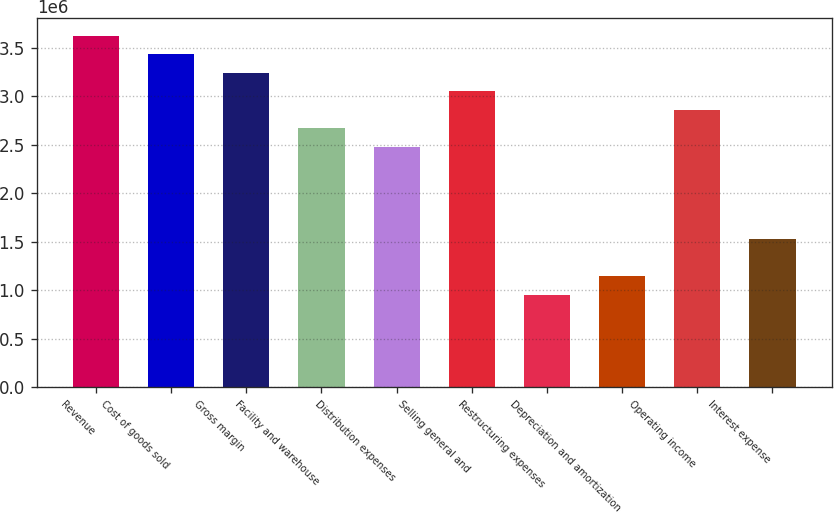<chart> <loc_0><loc_0><loc_500><loc_500><bar_chart><fcel>Revenue<fcel>Cost of goods sold<fcel>Gross margin<fcel>Facility and warehouse<fcel>Distribution expenses<fcel>Selling general and<fcel>Restructuring expenses<fcel>Depreciation and amortization<fcel>Operating income<fcel>Interest expense<nl><fcel>3.62621e+06<fcel>3.43536e+06<fcel>3.2445e+06<fcel>2.67194e+06<fcel>2.48109e+06<fcel>3.05365e+06<fcel>954266<fcel>1.14512e+06<fcel>2.8628e+06<fcel>1.52683e+06<nl></chart> 